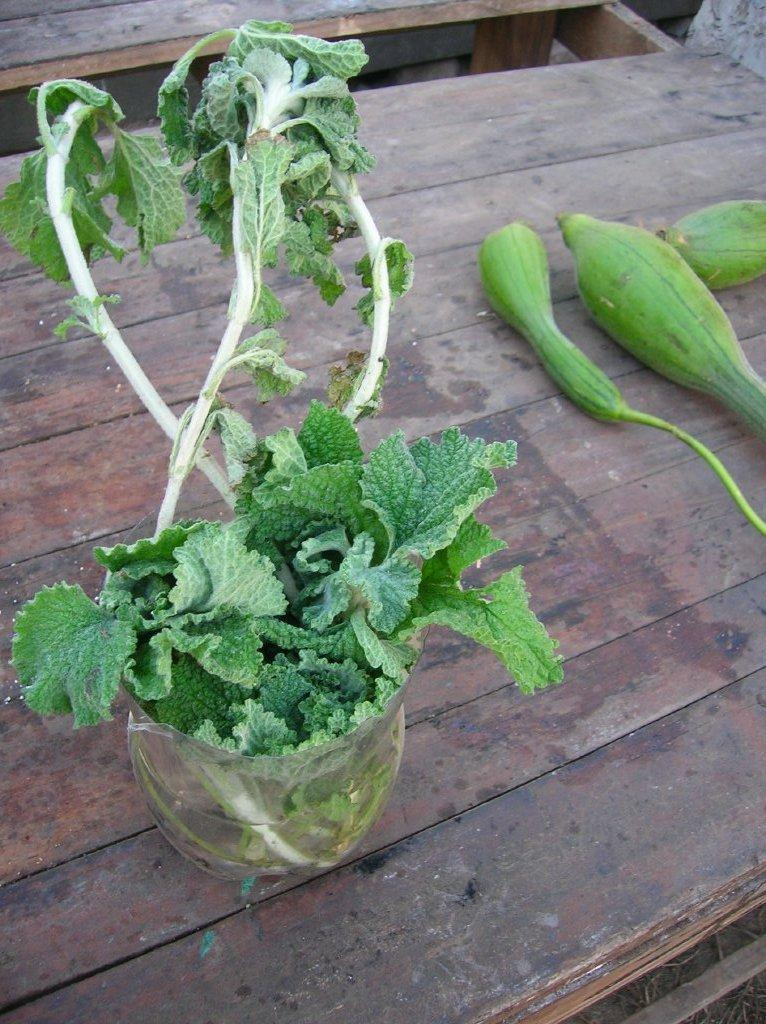What is the plant placed in, as seen in the image? There is a plant in a bowl. What type of vegetable can be seen on the wooden surface? Three cucumbers are present on a wooden surface. Where is the wooden surface located in the image? The wooden surface is in the middle of the image. What is the interest rate of the loan mentioned in the image? There is no mention of a loan or interest rate in the image. How many feet long is the plant in the bowl? The image does not provide information about the length of the plant in feet. 